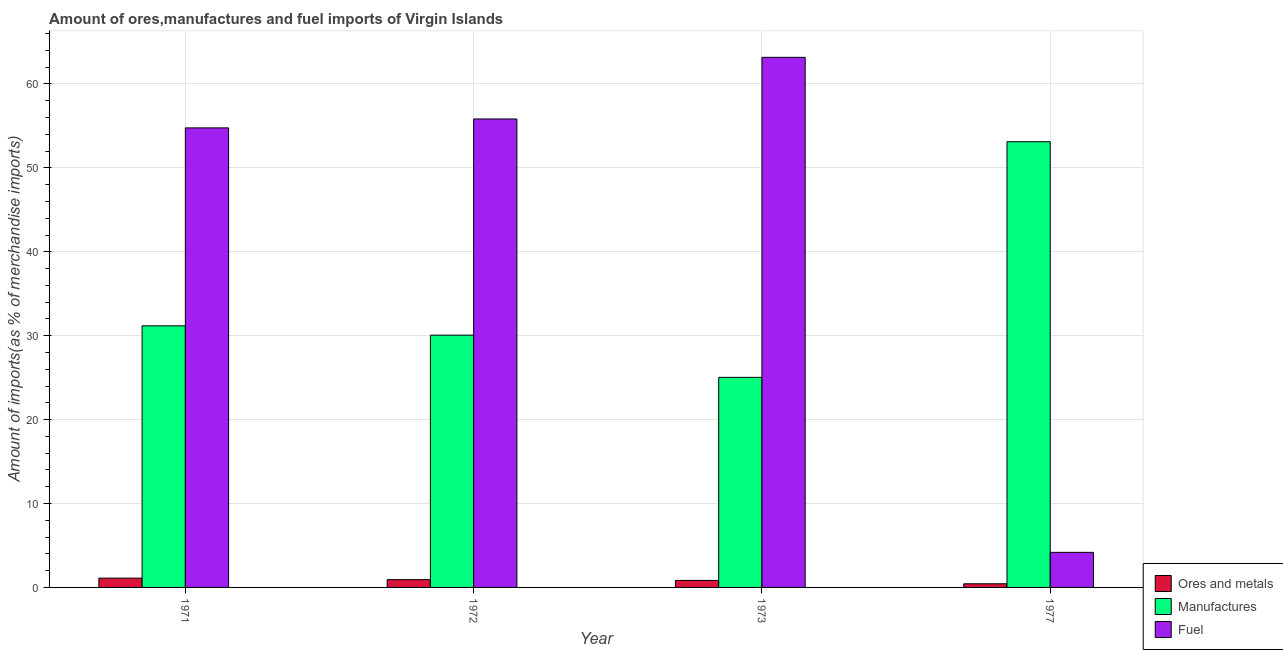How many groups of bars are there?
Provide a succinct answer. 4. How many bars are there on the 2nd tick from the left?
Offer a terse response. 3. In how many cases, is the number of bars for a given year not equal to the number of legend labels?
Provide a short and direct response. 0. What is the percentage of fuel imports in 1973?
Your answer should be compact. 63.18. Across all years, what is the maximum percentage of manufactures imports?
Ensure brevity in your answer.  53.12. Across all years, what is the minimum percentage of manufactures imports?
Provide a short and direct response. 25.04. In which year was the percentage of manufactures imports maximum?
Your answer should be compact. 1977. What is the total percentage of ores and metals imports in the graph?
Your answer should be compact. 3.31. What is the difference between the percentage of fuel imports in 1972 and that in 1973?
Your answer should be very brief. -7.34. What is the difference between the percentage of manufactures imports in 1977 and the percentage of ores and metals imports in 1972?
Your answer should be compact. 23.05. What is the average percentage of fuel imports per year?
Your answer should be very brief. 44.49. In the year 1977, what is the difference between the percentage of fuel imports and percentage of manufactures imports?
Keep it short and to the point. 0. What is the ratio of the percentage of fuel imports in 1971 to that in 1977?
Ensure brevity in your answer.  13.1. What is the difference between the highest and the second highest percentage of manufactures imports?
Your response must be concise. 21.94. What is the difference between the highest and the lowest percentage of fuel imports?
Keep it short and to the point. 59. In how many years, is the percentage of manufactures imports greater than the average percentage of manufactures imports taken over all years?
Make the answer very short. 1. Is the sum of the percentage of ores and metals imports in 1971 and 1973 greater than the maximum percentage of fuel imports across all years?
Provide a short and direct response. Yes. What does the 2nd bar from the left in 1973 represents?
Provide a succinct answer. Manufactures. What does the 3rd bar from the right in 1971 represents?
Give a very brief answer. Ores and metals. How many bars are there?
Offer a very short reply. 12. Are all the bars in the graph horizontal?
Offer a very short reply. No. Are the values on the major ticks of Y-axis written in scientific E-notation?
Give a very brief answer. No. How many legend labels are there?
Your answer should be very brief. 3. What is the title of the graph?
Your answer should be compact. Amount of ores,manufactures and fuel imports of Virgin Islands. What is the label or title of the X-axis?
Ensure brevity in your answer.  Year. What is the label or title of the Y-axis?
Ensure brevity in your answer.  Amount of imports(as % of merchandise imports). What is the Amount of imports(as % of merchandise imports) of Ores and metals in 1971?
Ensure brevity in your answer.  1.11. What is the Amount of imports(as % of merchandise imports) in Manufactures in 1971?
Give a very brief answer. 31.18. What is the Amount of imports(as % of merchandise imports) in Fuel in 1971?
Ensure brevity in your answer.  54.77. What is the Amount of imports(as % of merchandise imports) of Ores and metals in 1972?
Your response must be concise. 0.93. What is the Amount of imports(as % of merchandise imports) of Manufactures in 1972?
Provide a short and direct response. 30.07. What is the Amount of imports(as % of merchandise imports) of Fuel in 1972?
Provide a succinct answer. 55.83. What is the Amount of imports(as % of merchandise imports) in Ores and metals in 1973?
Keep it short and to the point. 0.83. What is the Amount of imports(as % of merchandise imports) in Manufactures in 1973?
Your answer should be compact. 25.04. What is the Amount of imports(as % of merchandise imports) of Fuel in 1973?
Ensure brevity in your answer.  63.18. What is the Amount of imports(as % of merchandise imports) of Ores and metals in 1977?
Provide a succinct answer. 0.43. What is the Amount of imports(as % of merchandise imports) in Manufactures in 1977?
Provide a short and direct response. 53.12. What is the Amount of imports(as % of merchandise imports) in Fuel in 1977?
Offer a terse response. 4.18. Across all years, what is the maximum Amount of imports(as % of merchandise imports) of Ores and metals?
Provide a succinct answer. 1.11. Across all years, what is the maximum Amount of imports(as % of merchandise imports) of Manufactures?
Offer a very short reply. 53.12. Across all years, what is the maximum Amount of imports(as % of merchandise imports) in Fuel?
Offer a terse response. 63.18. Across all years, what is the minimum Amount of imports(as % of merchandise imports) in Ores and metals?
Your answer should be very brief. 0.43. Across all years, what is the minimum Amount of imports(as % of merchandise imports) of Manufactures?
Your answer should be very brief. 25.04. Across all years, what is the minimum Amount of imports(as % of merchandise imports) of Fuel?
Your response must be concise. 4.18. What is the total Amount of imports(as % of merchandise imports) in Ores and metals in the graph?
Make the answer very short. 3.31. What is the total Amount of imports(as % of merchandise imports) in Manufactures in the graph?
Offer a very short reply. 139.4. What is the total Amount of imports(as % of merchandise imports) of Fuel in the graph?
Offer a terse response. 177.96. What is the difference between the Amount of imports(as % of merchandise imports) in Ores and metals in 1971 and that in 1972?
Ensure brevity in your answer.  0.18. What is the difference between the Amount of imports(as % of merchandise imports) of Manufactures in 1971 and that in 1972?
Offer a terse response. 1.11. What is the difference between the Amount of imports(as % of merchandise imports) of Fuel in 1971 and that in 1972?
Make the answer very short. -1.06. What is the difference between the Amount of imports(as % of merchandise imports) of Ores and metals in 1971 and that in 1973?
Ensure brevity in your answer.  0.27. What is the difference between the Amount of imports(as % of merchandise imports) in Manufactures in 1971 and that in 1973?
Ensure brevity in your answer.  6.14. What is the difference between the Amount of imports(as % of merchandise imports) of Fuel in 1971 and that in 1973?
Give a very brief answer. -8.41. What is the difference between the Amount of imports(as % of merchandise imports) in Ores and metals in 1971 and that in 1977?
Offer a terse response. 0.67. What is the difference between the Amount of imports(as % of merchandise imports) in Manufactures in 1971 and that in 1977?
Give a very brief answer. -21.94. What is the difference between the Amount of imports(as % of merchandise imports) of Fuel in 1971 and that in 1977?
Provide a succinct answer. 50.59. What is the difference between the Amount of imports(as % of merchandise imports) of Ores and metals in 1972 and that in 1973?
Make the answer very short. 0.09. What is the difference between the Amount of imports(as % of merchandise imports) of Manufactures in 1972 and that in 1973?
Ensure brevity in your answer.  5.03. What is the difference between the Amount of imports(as % of merchandise imports) of Fuel in 1972 and that in 1973?
Your answer should be very brief. -7.34. What is the difference between the Amount of imports(as % of merchandise imports) in Ores and metals in 1972 and that in 1977?
Offer a very short reply. 0.49. What is the difference between the Amount of imports(as % of merchandise imports) of Manufactures in 1972 and that in 1977?
Your answer should be compact. -23.05. What is the difference between the Amount of imports(as % of merchandise imports) in Fuel in 1972 and that in 1977?
Give a very brief answer. 51.65. What is the difference between the Amount of imports(as % of merchandise imports) of Ores and metals in 1973 and that in 1977?
Your answer should be very brief. 0.4. What is the difference between the Amount of imports(as % of merchandise imports) of Manufactures in 1973 and that in 1977?
Your response must be concise. -28.08. What is the difference between the Amount of imports(as % of merchandise imports) in Fuel in 1973 and that in 1977?
Ensure brevity in your answer.  59. What is the difference between the Amount of imports(as % of merchandise imports) in Ores and metals in 1971 and the Amount of imports(as % of merchandise imports) in Manufactures in 1972?
Give a very brief answer. -28.96. What is the difference between the Amount of imports(as % of merchandise imports) in Ores and metals in 1971 and the Amount of imports(as % of merchandise imports) in Fuel in 1972?
Provide a short and direct response. -54.72. What is the difference between the Amount of imports(as % of merchandise imports) in Manufactures in 1971 and the Amount of imports(as % of merchandise imports) in Fuel in 1972?
Provide a succinct answer. -24.66. What is the difference between the Amount of imports(as % of merchandise imports) in Ores and metals in 1971 and the Amount of imports(as % of merchandise imports) in Manufactures in 1973?
Make the answer very short. -23.93. What is the difference between the Amount of imports(as % of merchandise imports) of Ores and metals in 1971 and the Amount of imports(as % of merchandise imports) of Fuel in 1973?
Provide a succinct answer. -62.07. What is the difference between the Amount of imports(as % of merchandise imports) of Manufactures in 1971 and the Amount of imports(as % of merchandise imports) of Fuel in 1973?
Your answer should be very brief. -32. What is the difference between the Amount of imports(as % of merchandise imports) in Ores and metals in 1971 and the Amount of imports(as % of merchandise imports) in Manufactures in 1977?
Keep it short and to the point. -52.01. What is the difference between the Amount of imports(as % of merchandise imports) of Ores and metals in 1971 and the Amount of imports(as % of merchandise imports) of Fuel in 1977?
Your answer should be compact. -3.07. What is the difference between the Amount of imports(as % of merchandise imports) of Manufactures in 1971 and the Amount of imports(as % of merchandise imports) of Fuel in 1977?
Give a very brief answer. 27. What is the difference between the Amount of imports(as % of merchandise imports) of Ores and metals in 1972 and the Amount of imports(as % of merchandise imports) of Manufactures in 1973?
Give a very brief answer. -24.11. What is the difference between the Amount of imports(as % of merchandise imports) in Ores and metals in 1972 and the Amount of imports(as % of merchandise imports) in Fuel in 1973?
Offer a very short reply. -62.25. What is the difference between the Amount of imports(as % of merchandise imports) of Manufactures in 1972 and the Amount of imports(as % of merchandise imports) of Fuel in 1973?
Offer a very short reply. -33.11. What is the difference between the Amount of imports(as % of merchandise imports) in Ores and metals in 1972 and the Amount of imports(as % of merchandise imports) in Manufactures in 1977?
Your answer should be compact. -52.19. What is the difference between the Amount of imports(as % of merchandise imports) in Ores and metals in 1972 and the Amount of imports(as % of merchandise imports) in Fuel in 1977?
Your answer should be very brief. -3.25. What is the difference between the Amount of imports(as % of merchandise imports) in Manufactures in 1972 and the Amount of imports(as % of merchandise imports) in Fuel in 1977?
Make the answer very short. 25.89. What is the difference between the Amount of imports(as % of merchandise imports) in Ores and metals in 1973 and the Amount of imports(as % of merchandise imports) in Manufactures in 1977?
Keep it short and to the point. -52.28. What is the difference between the Amount of imports(as % of merchandise imports) in Ores and metals in 1973 and the Amount of imports(as % of merchandise imports) in Fuel in 1977?
Provide a succinct answer. -3.35. What is the difference between the Amount of imports(as % of merchandise imports) of Manufactures in 1973 and the Amount of imports(as % of merchandise imports) of Fuel in 1977?
Provide a short and direct response. 20.86. What is the average Amount of imports(as % of merchandise imports) of Ores and metals per year?
Make the answer very short. 0.83. What is the average Amount of imports(as % of merchandise imports) in Manufactures per year?
Your answer should be very brief. 34.85. What is the average Amount of imports(as % of merchandise imports) in Fuel per year?
Provide a succinct answer. 44.49. In the year 1971, what is the difference between the Amount of imports(as % of merchandise imports) in Ores and metals and Amount of imports(as % of merchandise imports) in Manufactures?
Make the answer very short. -30.07. In the year 1971, what is the difference between the Amount of imports(as % of merchandise imports) of Ores and metals and Amount of imports(as % of merchandise imports) of Fuel?
Your answer should be very brief. -53.66. In the year 1971, what is the difference between the Amount of imports(as % of merchandise imports) of Manufactures and Amount of imports(as % of merchandise imports) of Fuel?
Make the answer very short. -23.59. In the year 1972, what is the difference between the Amount of imports(as % of merchandise imports) of Ores and metals and Amount of imports(as % of merchandise imports) of Manufactures?
Make the answer very short. -29.14. In the year 1972, what is the difference between the Amount of imports(as % of merchandise imports) in Ores and metals and Amount of imports(as % of merchandise imports) in Fuel?
Keep it short and to the point. -54.9. In the year 1972, what is the difference between the Amount of imports(as % of merchandise imports) of Manufactures and Amount of imports(as % of merchandise imports) of Fuel?
Your answer should be compact. -25.77. In the year 1973, what is the difference between the Amount of imports(as % of merchandise imports) in Ores and metals and Amount of imports(as % of merchandise imports) in Manufactures?
Your response must be concise. -24.2. In the year 1973, what is the difference between the Amount of imports(as % of merchandise imports) in Ores and metals and Amount of imports(as % of merchandise imports) in Fuel?
Keep it short and to the point. -62.34. In the year 1973, what is the difference between the Amount of imports(as % of merchandise imports) in Manufactures and Amount of imports(as % of merchandise imports) in Fuel?
Ensure brevity in your answer.  -38.14. In the year 1977, what is the difference between the Amount of imports(as % of merchandise imports) in Ores and metals and Amount of imports(as % of merchandise imports) in Manufactures?
Your answer should be very brief. -52.68. In the year 1977, what is the difference between the Amount of imports(as % of merchandise imports) in Ores and metals and Amount of imports(as % of merchandise imports) in Fuel?
Offer a terse response. -3.75. In the year 1977, what is the difference between the Amount of imports(as % of merchandise imports) in Manufactures and Amount of imports(as % of merchandise imports) in Fuel?
Provide a short and direct response. 48.94. What is the ratio of the Amount of imports(as % of merchandise imports) of Ores and metals in 1971 to that in 1972?
Offer a terse response. 1.19. What is the ratio of the Amount of imports(as % of merchandise imports) of Manufactures in 1971 to that in 1972?
Your answer should be compact. 1.04. What is the ratio of the Amount of imports(as % of merchandise imports) in Fuel in 1971 to that in 1972?
Ensure brevity in your answer.  0.98. What is the ratio of the Amount of imports(as % of merchandise imports) in Ores and metals in 1971 to that in 1973?
Make the answer very short. 1.33. What is the ratio of the Amount of imports(as % of merchandise imports) in Manufactures in 1971 to that in 1973?
Make the answer very short. 1.25. What is the ratio of the Amount of imports(as % of merchandise imports) in Fuel in 1971 to that in 1973?
Your response must be concise. 0.87. What is the ratio of the Amount of imports(as % of merchandise imports) of Ores and metals in 1971 to that in 1977?
Keep it short and to the point. 2.55. What is the ratio of the Amount of imports(as % of merchandise imports) in Manufactures in 1971 to that in 1977?
Ensure brevity in your answer.  0.59. What is the ratio of the Amount of imports(as % of merchandise imports) of Fuel in 1971 to that in 1977?
Provide a succinct answer. 13.1. What is the ratio of the Amount of imports(as % of merchandise imports) of Ores and metals in 1972 to that in 1973?
Your response must be concise. 1.11. What is the ratio of the Amount of imports(as % of merchandise imports) of Manufactures in 1972 to that in 1973?
Offer a very short reply. 1.2. What is the ratio of the Amount of imports(as % of merchandise imports) in Fuel in 1972 to that in 1973?
Your answer should be compact. 0.88. What is the ratio of the Amount of imports(as % of merchandise imports) of Ores and metals in 1972 to that in 1977?
Ensure brevity in your answer.  2.14. What is the ratio of the Amount of imports(as % of merchandise imports) in Manufactures in 1972 to that in 1977?
Your answer should be very brief. 0.57. What is the ratio of the Amount of imports(as % of merchandise imports) of Fuel in 1972 to that in 1977?
Make the answer very short. 13.36. What is the ratio of the Amount of imports(as % of merchandise imports) in Ores and metals in 1973 to that in 1977?
Offer a very short reply. 1.92. What is the ratio of the Amount of imports(as % of merchandise imports) of Manufactures in 1973 to that in 1977?
Give a very brief answer. 0.47. What is the ratio of the Amount of imports(as % of merchandise imports) of Fuel in 1973 to that in 1977?
Keep it short and to the point. 15.11. What is the difference between the highest and the second highest Amount of imports(as % of merchandise imports) in Ores and metals?
Offer a very short reply. 0.18. What is the difference between the highest and the second highest Amount of imports(as % of merchandise imports) in Manufactures?
Give a very brief answer. 21.94. What is the difference between the highest and the second highest Amount of imports(as % of merchandise imports) in Fuel?
Make the answer very short. 7.34. What is the difference between the highest and the lowest Amount of imports(as % of merchandise imports) of Ores and metals?
Provide a succinct answer. 0.67. What is the difference between the highest and the lowest Amount of imports(as % of merchandise imports) in Manufactures?
Your answer should be compact. 28.08. What is the difference between the highest and the lowest Amount of imports(as % of merchandise imports) of Fuel?
Your answer should be compact. 59. 